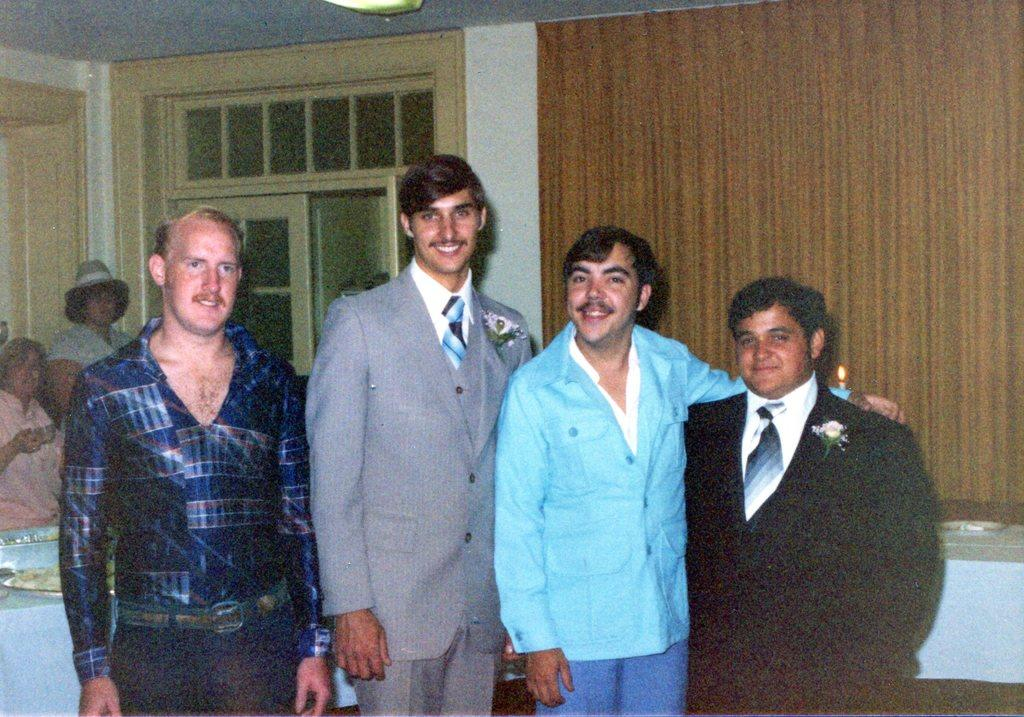How many men are present in the image? There are four men in the image. What are the men doing in the image? The men are standing and smiling. What can be seen in the background of the image? There is a curtain and a door in the background of the image. Are there any other people visible in the image? Yes, there are two persons in the background of the image. What type of health advice can be seen on the curtain in the image? There is no health advice visible on the curtain in the image. What type of bushes are growing in the background of the image? There are no bushes present in the background of the image. 